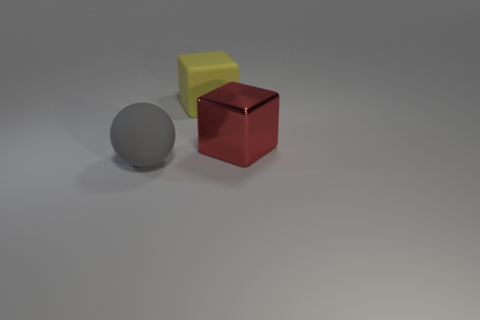Is there anything else that has the same material as the large red thing?
Keep it short and to the point. No. Are there any gray rubber things in front of the matte object behind the object left of the matte block?
Provide a short and direct response. Yes. What number of yellow blocks are the same size as the yellow object?
Offer a very short reply. 0. There is a rubber object that is behind the large gray matte thing; is it the same size as the thing that is in front of the big red thing?
Your response must be concise. Yes. There is a big thing that is behind the big sphere and in front of the yellow block; what shape is it?
Your answer should be very brief. Cube. Are any purple shiny objects visible?
Your answer should be very brief. No. There is a thing behind the large red object; what is its color?
Offer a terse response. Yellow. How big is the thing that is to the left of the shiny block and in front of the yellow matte block?
Ensure brevity in your answer.  Large. Are there any yellow things that have the same material as the gray sphere?
Make the answer very short. Yes. There is a red metal object; what shape is it?
Ensure brevity in your answer.  Cube. 